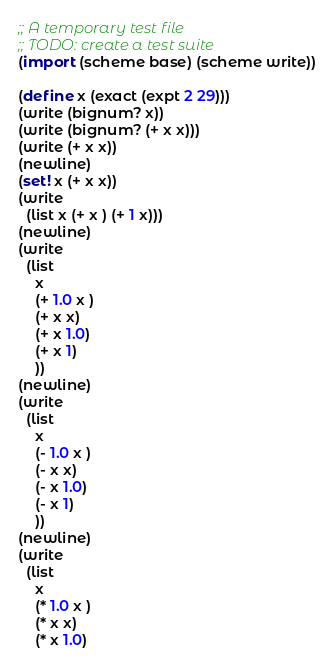<code> <loc_0><loc_0><loc_500><loc_500><_Scheme_>;; A temporary test file
;; TODO: create a test suite
(import (scheme base) (scheme write))

(define x (exact (expt 2 29)))
(write (bignum? x))
(write (bignum? (+ x x)))
(write (+ x x))
(newline)
(set! x (+ x x))
(write
  (list x (+ x ) (+ 1 x)))
(newline)
(write
  (list 
    x 
    (+ 1.0 x ) 
    (+ x x) 
    (+ x 1.0) 
    (+ x 1)
    ))
(newline)
(write
  (list 
    x 
    (- 1.0 x ) 
    (- x x) 
    (- x 1.0) 
    (- x 1)
    ))
(newline)
(write
  (list 
    x 
    (* 1.0 x ) 
    (* x x) 
    (* x 1.0) </code> 